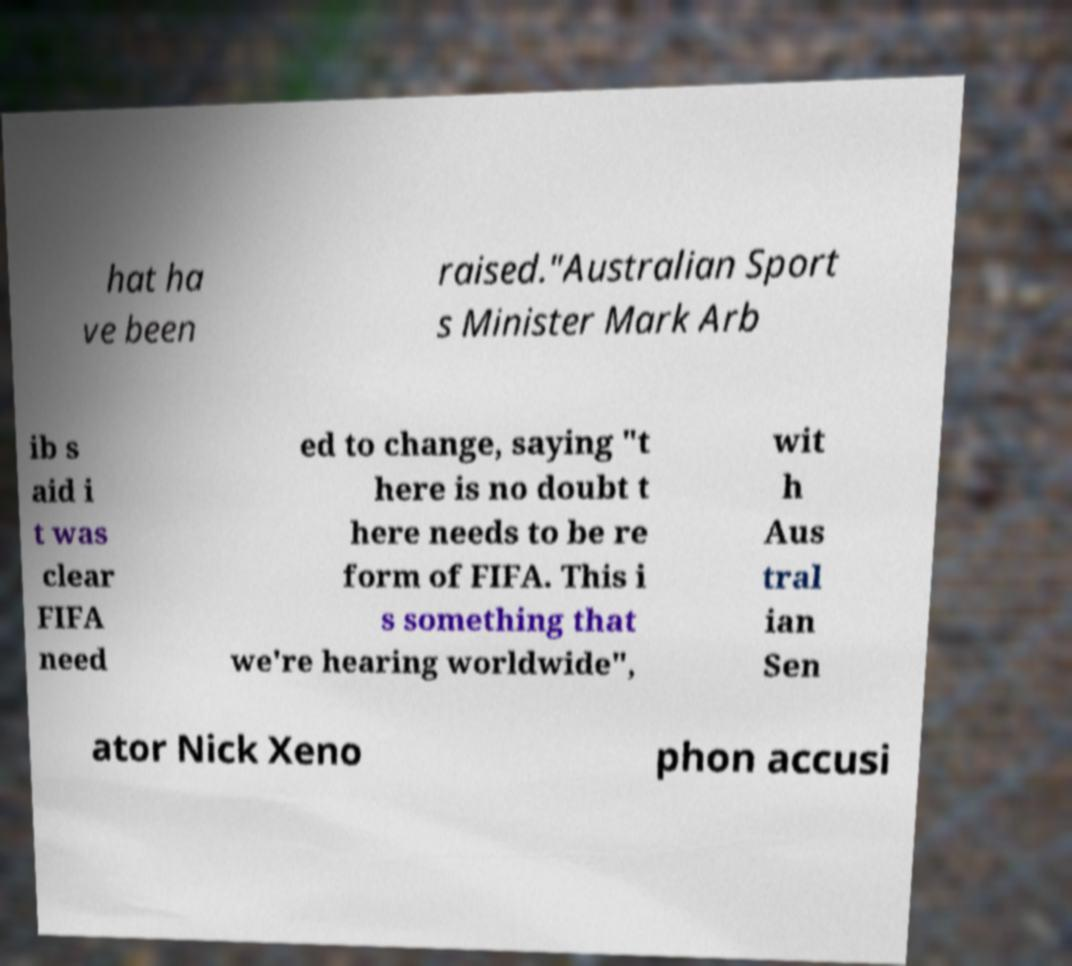Please read and relay the text visible in this image. What does it say? hat ha ve been raised."Australian Sport s Minister Mark Arb ib s aid i t was clear FIFA need ed to change, saying "t here is no doubt t here needs to be re form of FIFA. This i s something that we're hearing worldwide", wit h Aus tral ian Sen ator Nick Xeno phon accusi 